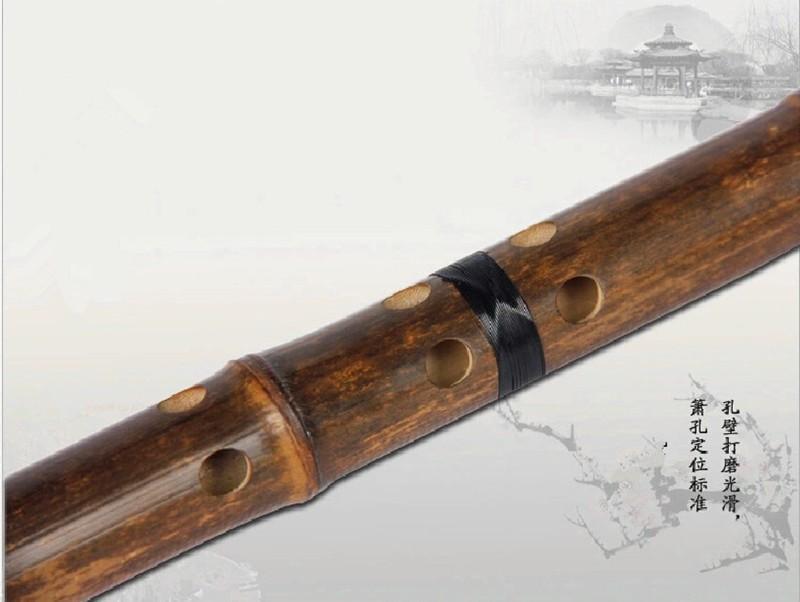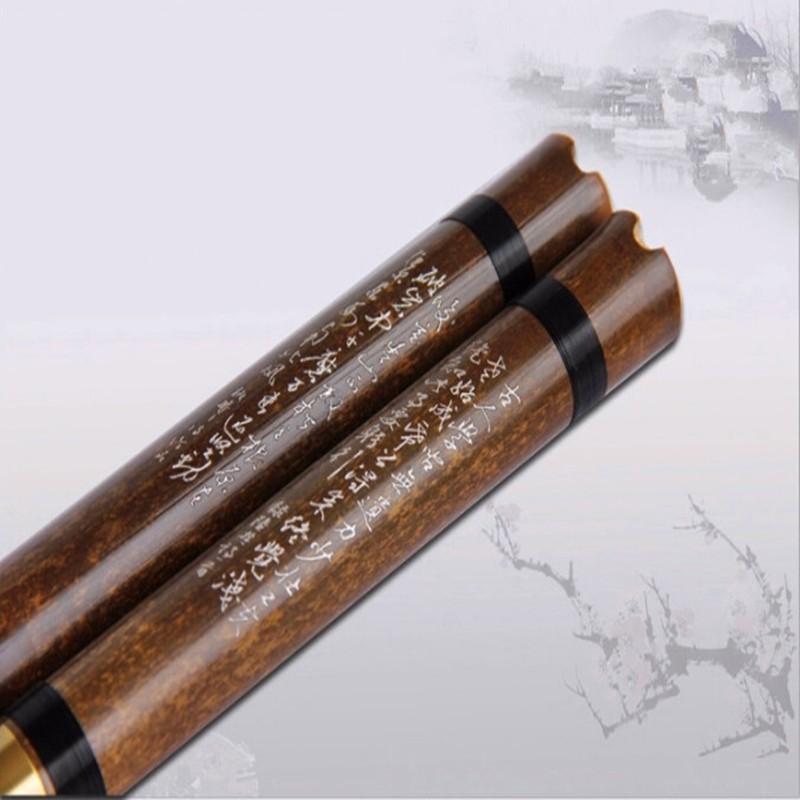The first image is the image on the left, the second image is the image on the right. For the images shown, is this caption "In the left image, we've got two flute parts parallel to each other." true? Answer yes or no. No. The first image is the image on the left, the second image is the image on the right. Evaluate the accuracy of this statement regarding the images: "There is a single flute bar with the left side at the bottom, there are no other pieces in the image.". Is it true? Answer yes or no. Yes. 